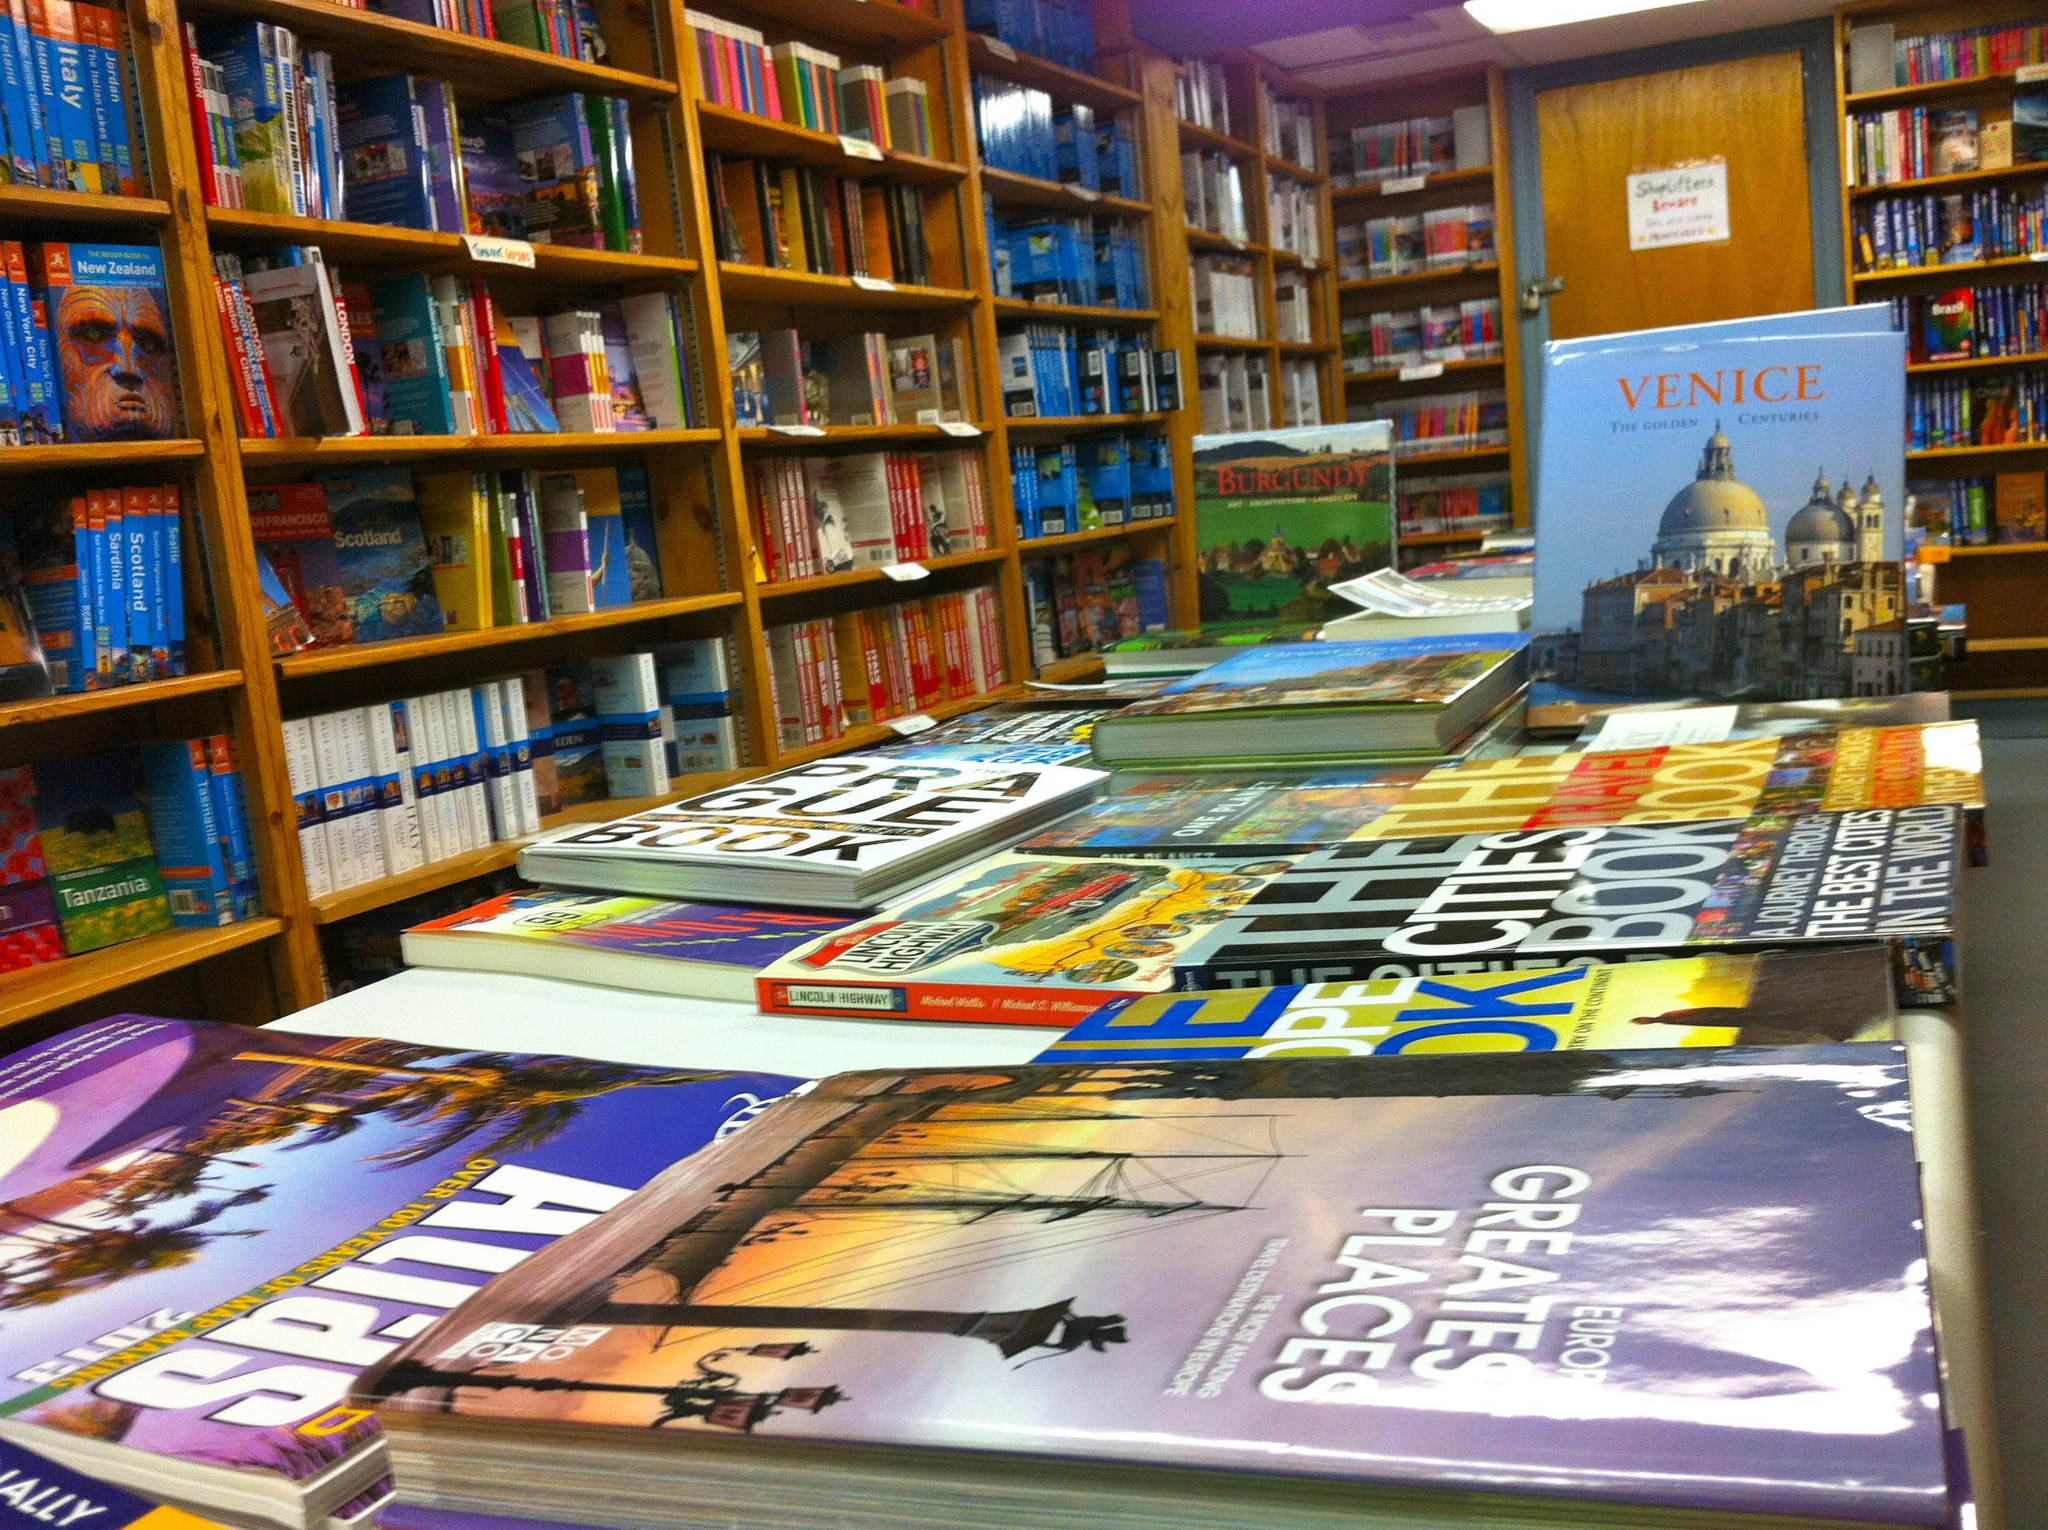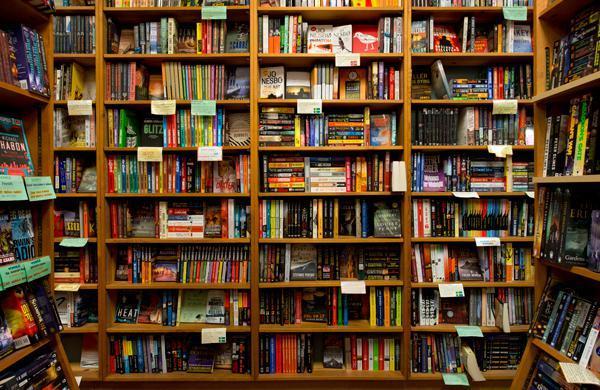The first image is the image on the left, the second image is the image on the right. Analyze the images presented: Is the assertion "A yellow sign sits on the sidewalk in the image on the right." valid? Answer yes or no. No. 